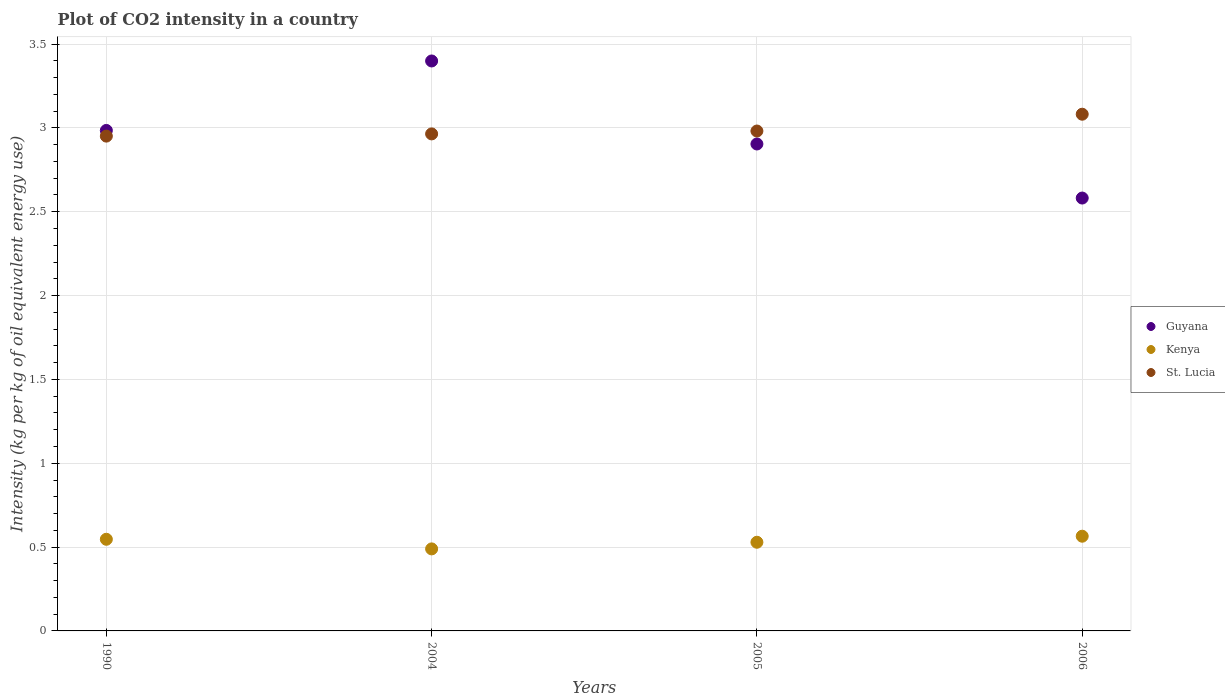How many different coloured dotlines are there?
Offer a terse response. 3. Is the number of dotlines equal to the number of legend labels?
Offer a very short reply. Yes. What is the CO2 intensity in in Kenya in 2005?
Your answer should be very brief. 0.53. Across all years, what is the maximum CO2 intensity in in Guyana?
Your answer should be compact. 3.4. Across all years, what is the minimum CO2 intensity in in Kenya?
Ensure brevity in your answer.  0.49. In which year was the CO2 intensity in in Guyana maximum?
Your response must be concise. 2004. In which year was the CO2 intensity in in St. Lucia minimum?
Your answer should be very brief. 1990. What is the total CO2 intensity in in Guyana in the graph?
Your answer should be very brief. 11.87. What is the difference between the CO2 intensity in in Guyana in 1990 and that in 2006?
Your answer should be very brief. 0.4. What is the difference between the CO2 intensity in in Guyana in 2004 and the CO2 intensity in in St. Lucia in 2005?
Your response must be concise. 0.42. What is the average CO2 intensity in in St. Lucia per year?
Your answer should be compact. 2.99. In the year 2005, what is the difference between the CO2 intensity in in Kenya and CO2 intensity in in Guyana?
Offer a terse response. -2.38. What is the ratio of the CO2 intensity in in St. Lucia in 2004 to that in 2005?
Provide a succinct answer. 0.99. Is the CO2 intensity in in Guyana in 2004 less than that in 2006?
Your answer should be compact. No. Is the difference between the CO2 intensity in in Kenya in 1990 and 2004 greater than the difference between the CO2 intensity in in Guyana in 1990 and 2004?
Provide a short and direct response. Yes. What is the difference between the highest and the second highest CO2 intensity in in Kenya?
Make the answer very short. 0.02. What is the difference between the highest and the lowest CO2 intensity in in Kenya?
Offer a terse response. 0.08. Is the sum of the CO2 intensity in in St. Lucia in 1990 and 2006 greater than the maximum CO2 intensity in in Guyana across all years?
Ensure brevity in your answer.  Yes. Is it the case that in every year, the sum of the CO2 intensity in in Guyana and CO2 intensity in in Kenya  is greater than the CO2 intensity in in St. Lucia?
Your answer should be compact. Yes. Is the CO2 intensity in in Guyana strictly greater than the CO2 intensity in in St. Lucia over the years?
Ensure brevity in your answer.  No. Is the CO2 intensity in in Guyana strictly less than the CO2 intensity in in Kenya over the years?
Your answer should be very brief. No. How many dotlines are there?
Offer a very short reply. 3. Does the graph contain grids?
Provide a short and direct response. Yes. Where does the legend appear in the graph?
Provide a short and direct response. Center right. How are the legend labels stacked?
Make the answer very short. Vertical. What is the title of the graph?
Your answer should be very brief. Plot of CO2 intensity in a country. What is the label or title of the Y-axis?
Your answer should be very brief. Intensity (kg per kg of oil equivalent energy use). What is the Intensity (kg per kg of oil equivalent energy use) of Guyana in 1990?
Offer a terse response. 2.98. What is the Intensity (kg per kg of oil equivalent energy use) in Kenya in 1990?
Give a very brief answer. 0.55. What is the Intensity (kg per kg of oil equivalent energy use) in St. Lucia in 1990?
Make the answer very short. 2.95. What is the Intensity (kg per kg of oil equivalent energy use) of Guyana in 2004?
Your response must be concise. 3.4. What is the Intensity (kg per kg of oil equivalent energy use) in Kenya in 2004?
Provide a succinct answer. 0.49. What is the Intensity (kg per kg of oil equivalent energy use) in St. Lucia in 2004?
Offer a very short reply. 2.96. What is the Intensity (kg per kg of oil equivalent energy use) in Guyana in 2005?
Provide a short and direct response. 2.9. What is the Intensity (kg per kg of oil equivalent energy use) in Kenya in 2005?
Your answer should be compact. 0.53. What is the Intensity (kg per kg of oil equivalent energy use) in St. Lucia in 2005?
Ensure brevity in your answer.  2.98. What is the Intensity (kg per kg of oil equivalent energy use) in Guyana in 2006?
Keep it short and to the point. 2.58. What is the Intensity (kg per kg of oil equivalent energy use) in Kenya in 2006?
Ensure brevity in your answer.  0.56. What is the Intensity (kg per kg of oil equivalent energy use) in St. Lucia in 2006?
Ensure brevity in your answer.  3.08. Across all years, what is the maximum Intensity (kg per kg of oil equivalent energy use) of Guyana?
Your response must be concise. 3.4. Across all years, what is the maximum Intensity (kg per kg of oil equivalent energy use) in Kenya?
Your answer should be very brief. 0.56. Across all years, what is the maximum Intensity (kg per kg of oil equivalent energy use) of St. Lucia?
Give a very brief answer. 3.08. Across all years, what is the minimum Intensity (kg per kg of oil equivalent energy use) of Guyana?
Ensure brevity in your answer.  2.58. Across all years, what is the minimum Intensity (kg per kg of oil equivalent energy use) in Kenya?
Make the answer very short. 0.49. Across all years, what is the minimum Intensity (kg per kg of oil equivalent energy use) in St. Lucia?
Offer a terse response. 2.95. What is the total Intensity (kg per kg of oil equivalent energy use) in Guyana in the graph?
Ensure brevity in your answer.  11.87. What is the total Intensity (kg per kg of oil equivalent energy use) in Kenya in the graph?
Your answer should be compact. 2.13. What is the total Intensity (kg per kg of oil equivalent energy use) in St. Lucia in the graph?
Your answer should be compact. 11.98. What is the difference between the Intensity (kg per kg of oil equivalent energy use) of Guyana in 1990 and that in 2004?
Give a very brief answer. -0.41. What is the difference between the Intensity (kg per kg of oil equivalent energy use) of Kenya in 1990 and that in 2004?
Make the answer very short. 0.06. What is the difference between the Intensity (kg per kg of oil equivalent energy use) of St. Lucia in 1990 and that in 2004?
Ensure brevity in your answer.  -0.01. What is the difference between the Intensity (kg per kg of oil equivalent energy use) of Guyana in 1990 and that in 2005?
Keep it short and to the point. 0.08. What is the difference between the Intensity (kg per kg of oil equivalent energy use) of Kenya in 1990 and that in 2005?
Provide a short and direct response. 0.02. What is the difference between the Intensity (kg per kg of oil equivalent energy use) of St. Lucia in 1990 and that in 2005?
Provide a succinct answer. -0.03. What is the difference between the Intensity (kg per kg of oil equivalent energy use) of Guyana in 1990 and that in 2006?
Give a very brief answer. 0.4. What is the difference between the Intensity (kg per kg of oil equivalent energy use) in Kenya in 1990 and that in 2006?
Ensure brevity in your answer.  -0.02. What is the difference between the Intensity (kg per kg of oil equivalent energy use) of St. Lucia in 1990 and that in 2006?
Provide a succinct answer. -0.13. What is the difference between the Intensity (kg per kg of oil equivalent energy use) of Guyana in 2004 and that in 2005?
Provide a short and direct response. 0.5. What is the difference between the Intensity (kg per kg of oil equivalent energy use) in Kenya in 2004 and that in 2005?
Provide a succinct answer. -0.04. What is the difference between the Intensity (kg per kg of oil equivalent energy use) in St. Lucia in 2004 and that in 2005?
Offer a terse response. -0.02. What is the difference between the Intensity (kg per kg of oil equivalent energy use) of Guyana in 2004 and that in 2006?
Make the answer very short. 0.82. What is the difference between the Intensity (kg per kg of oil equivalent energy use) of Kenya in 2004 and that in 2006?
Give a very brief answer. -0.08. What is the difference between the Intensity (kg per kg of oil equivalent energy use) of St. Lucia in 2004 and that in 2006?
Ensure brevity in your answer.  -0.12. What is the difference between the Intensity (kg per kg of oil equivalent energy use) in Guyana in 2005 and that in 2006?
Offer a very short reply. 0.32. What is the difference between the Intensity (kg per kg of oil equivalent energy use) in Kenya in 2005 and that in 2006?
Offer a terse response. -0.04. What is the difference between the Intensity (kg per kg of oil equivalent energy use) of St. Lucia in 2005 and that in 2006?
Ensure brevity in your answer.  -0.1. What is the difference between the Intensity (kg per kg of oil equivalent energy use) of Guyana in 1990 and the Intensity (kg per kg of oil equivalent energy use) of Kenya in 2004?
Provide a short and direct response. 2.5. What is the difference between the Intensity (kg per kg of oil equivalent energy use) in Guyana in 1990 and the Intensity (kg per kg of oil equivalent energy use) in St. Lucia in 2004?
Give a very brief answer. 0.02. What is the difference between the Intensity (kg per kg of oil equivalent energy use) in Kenya in 1990 and the Intensity (kg per kg of oil equivalent energy use) in St. Lucia in 2004?
Provide a short and direct response. -2.42. What is the difference between the Intensity (kg per kg of oil equivalent energy use) in Guyana in 1990 and the Intensity (kg per kg of oil equivalent energy use) in Kenya in 2005?
Your response must be concise. 2.46. What is the difference between the Intensity (kg per kg of oil equivalent energy use) of Guyana in 1990 and the Intensity (kg per kg of oil equivalent energy use) of St. Lucia in 2005?
Ensure brevity in your answer.  0. What is the difference between the Intensity (kg per kg of oil equivalent energy use) in Kenya in 1990 and the Intensity (kg per kg of oil equivalent energy use) in St. Lucia in 2005?
Give a very brief answer. -2.43. What is the difference between the Intensity (kg per kg of oil equivalent energy use) in Guyana in 1990 and the Intensity (kg per kg of oil equivalent energy use) in Kenya in 2006?
Ensure brevity in your answer.  2.42. What is the difference between the Intensity (kg per kg of oil equivalent energy use) of Guyana in 1990 and the Intensity (kg per kg of oil equivalent energy use) of St. Lucia in 2006?
Make the answer very short. -0.1. What is the difference between the Intensity (kg per kg of oil equivalent energy use) of Kenya in 1990 and the Intensity (kg per kg of oil equivalent energy use) of St. Lucia in 2006?
Ensure brevity in your answer.  -2.54. What is the difference between the Intensity (kg per kg of oil equivalent energy use) in Guyana in 2004 and the Intensity (kg per kg of oil equivalent energy use) in Kenya in 2005?
Offer a very short reply. 2.87. What is the difference between the Intensity (kg per kg of oil equivalent energy use) in Guyana in 2004 and the Intensity (kg per kg of oil equivalent energy use) in St. Lucia in 2005?
Your response must be concise. 0.42. What is the difference between the Intensity (kg per kg of oil equivalent energy use) of Kenya in 2004 and the Intensity (kg per kg of oil equivalent energy use) of St. Lucia in 2005?
Provide a succinct answer. -2.49. What is the difference between the Intensity (kg per kg of oil equivalent energy use) of Guyana in 2004 and the Intensity (kg per kg of oil equivalent energy use) of Kenya in 2006?
Offer a very short reply. 2.83. What is the difference between the Intensity (kg per kg of oil equivalent energy use) of Guyana in 2004 and the Intensity (kg per kg of oil equivalent energy use) of St. Lucia in 2006?
Your answer should be very brief. 0.32. What is the difference between the Intensity (kg per kg of oil equivalent energy use) of Kenya in 2004 and the Intensity (kg per kg of oil equivalent energy use) of St. Lucia in 2006?
Your answer should be compact. -2.59. What is the difference between the Intensity (kg per kg of oil equivalent energy use) of Guyana in 2005 and the Intensity (kg per kg of oil equivalent energy use) of Kenya in 2006?
Make the answer very short. 2.34. What is the difference between the Intensity (kg per kg of oil equivalent energy use) in Guyana in 2005 and the Intensity (kg per kg of oil equivalent energy use) in St. Lucia in 2006?
Offer a very short reply. -0.18. What is the difference between the Intensity (kg per kg of oil equivalent energy use) of Kenya in 2005 and the Intensity (kg per kg of oil equivalent energy use) of St. Lucia in 2006?
Provide a succinct answer. -2.55. What is the average Intensity (kg per kg of oil equivalent energy use) of Guyana per year?
Your response must be concise. 2.97. What is the average Intensity (kg per kg of oil equivalent energy use) in Kenya per year?
Your answer should be compact. 0.53. What is the average Intensity (kg per kg of oil equivalent energy use) of St. Lucia per year?
Your answer should be very brief. 2.99. In the year 1990, what is the difference between the Intensity (kg per kg of oil equivalent energy use) in Guyana and Intensity (kg per kg of oil equivalent energy use) in Kenya?
Ensure brevity in your answer.  2.44. In the year 1990, what is the difference between the Intensity (kg per kg of oil equivalent energy use) in Guyana and Intensity (kg per kg of oil equivalent energy use) in St. Lucia?
Provide a succinct answer. 0.03. In the year 1990, what is the difference between the Intensity (kg per kg of oil equivalent energy use) of Kenya and Intensity (kg per kg of oil equivalent energy use) of St. Lucia?
Your response must be concise. -2.4. In the year 2004, what is the difference between the Intensity (kg per kg of oil equivalent energy use) in Guyana and Intensity (kg per kg of oil equivalent energy use) in Kenya?
Your answer should be very brief. 2.91. In the year 2004, what is the difference between the Intensity (kg per kg of oil equivalent energy use) in Guyana and Intensity (kg per kg of oil equivalent energy use) in St. Lucia?
Keep it short and to the point. 0.43. In the year 2004, what is the difference between the Intensity (kg per kg of oil equivalent energy use) of Kenya and Intensity (kg per kg of oil equivalent energy use) of St. Lucia?
Offer a terse response. -2.48. In the year 2005, what is the difference between the Intensity (kg per kg of oil equivalent energy use) of Guyana and Intensity (kg per kg of oil equivalent energy use) of Kenya?
Offer a very short reply. 2.38. In the year 2005, what is the difference between the Intensity (kg per kg of oil equivalent energy use) of Guyana and Intensity (kg per kg of oil equivalent energy use) of St. Lucia?
Offer a terse response. -0.08. In the year 2005, what is the difference between the Intensity (kg per kg of oil equivalent energy use) in Kenya and Intensity (kg per kg of oil equivalent energy use) in St. Lucia?
Your answer should be very brief. -2.45. In the year 2006, what is the difference between the Intensity (kg per kg of oil equivalent energy use) in Guyana and Intensity (kg per kg of oil equivalent energy use) in Kenya?
Your answer should be very brief. 2.02. In the year 2006, what is the difference between the Intensity (kg per kg of oil equivalent energy use) of Guyana and Intensity (kg per kg of oil equivalent energy use) of St. Lucia?
Your answer should be compact. -0.5. In the year 2006, what is the difference between the Intensity (kg per kg of oil equivalent energy use) of Kenya and Intensity (kg per kg of oil equivalent energy use) of St. Lucia?
Your response must be concise. -2.52. What is the ratio of the Intensity (kg per kg of oil equivalent energy use) of Guyana in 1990 to that in 2004?
Your answer should be compact. 0.88. What is the ratio of the Intensity (kg per kg of oil equivalent energy use) in Kenya in 1990 to that in 2004?
Offer a very short reply. 1.12. What is the ratio of the Intensity (kg per kg of oil equivalent energy use) in St. Lucia in 1990 to that in 2004?
Provide a succinct answer. 1. What is the ratio of the Intensity (kg per kg of oil equivalent energy use) in Guyana in 1990 to that in 2005?
Your answer should be very brief. 1.03. What is the ratio of the Intensity (kg per kg of oil equivalent energy use) in Kenya in 1990 to that in 2005?
Offer a very short reply. 1.03. What is the ratio of the Intensity (kg per kg of oil equivalent energy use) of Guyana in 1990 to that in 2006?
Your response must be concise. 1.16. What is the ratio of the Intensity (kg per kg of oil equivalent energy use) of Kenya in 1990 to that in 2006?
Give a very brief answer. 0.97. What is the ratio of the Intensity (kg per kg of oil equivalent energy use) in St. Lucia in 1990 to that in 2006?
Keep it short and to the point. 0.96. What is the ratio of the Intensity (kg per kg of oil equivalent energy use) in Guyana in 2004 to that in 2005?
Offer a very short reply. 1.17. What is the ratio of the Intensity (kg per kg of oil equivalent energy use) in Kenya in 2004 to that in 2005?
Your answer should be very brief. 0.93. What is the ratio of the Intensity (kg per kg of oil equivalent energy use) in St. Lucia in 2004 to that in 2005?
Your response must be concise. 0.99. What is the ratio of the Intensity (kg per kg of oil equivalent energy use) in Guyana in 2004 to that in 2006?
Your response must be concise. 1.32. What is the ratio of the Intensity (kg per kg of oil equivalent energy use) of Kenya in 2004 to that in 2006?
Offer a very short reply. 0.87. What is the ratio of the Intensity (kg per kg of oil equivalent energy use) in St. Lucia in 2004 to that in 2006?
Offer a very short reply. 0.96. What is the ratio of the Intensity (kg per kg of oil equivalent energy use) of Guyana in 2005 to that in 2006?
Give a very brief answer. 1.12. What is the ratio of the Intensity (kg per kg of oil equivalent energy use) in Kenya in 2005 to that in 2006?
Your response must be concise. 0.94. What is the ratio of the Intensity (kg per kg of oil equivalent energy use) of St. Lucia in 2005 to that in 2006?
Provide a short and direct response. 0.97. What is the difference between the highest and the second highest Intensity (kg per kg of oil equivalent energy use) in Guyana?
Offer a terse response. 0.41. What is the difference between the highest and the second highest Intensity (kg per kg of oil equivalent energy use) of Kenya?
Your answer should be very brief. 0.02. What is the difference between the highest and the second highest Intensity (kg per kg of oil equivalent energy use) in St. Lucia?
Keep it short and to the point. 0.1. What is the difference between the highest and the lowest Intensity (kg per kg of oil equivalent energy use) of Guyana?
Your response must be concise. 0.82. What is the difference between the highest and the lowest Intensity (kg per kg of oil equivalent energy use) in Kenya?
Offer a very short reply. 0.08. What is the difference between the highest and the lowest Intensity (kg per kg of oil equivalent energy use) of St. Lucia?
Keep it short and to the point. 0.13. 